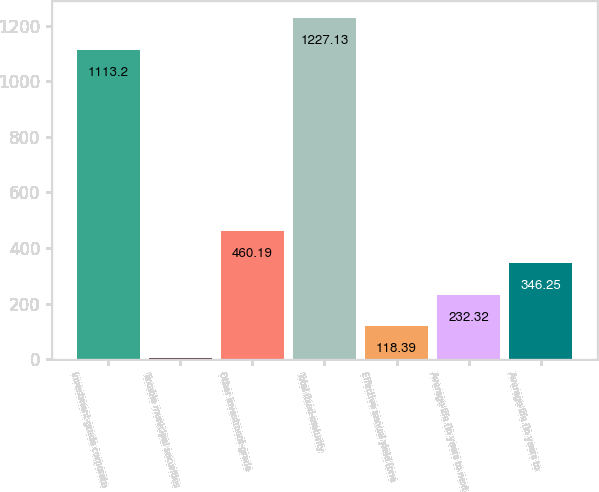<chart> <loc_0><loc_0><loc_500><loc_500><bar_chart><fcel>Investment-grade corporate<fcel>Taxable municipal securities<fcel>Other investment-grade<fcel>Total fixed-maturity<fcel>Effective annual yield (one<fcel>Average life (in years to next<fcel>Average life (in years to<nl><fcel>1113.2<fcel>4.45<fcel>460.19<fcel>1227.13<fcel>118.39<fcel>232.32<fcel>346.25<nl></chart> 